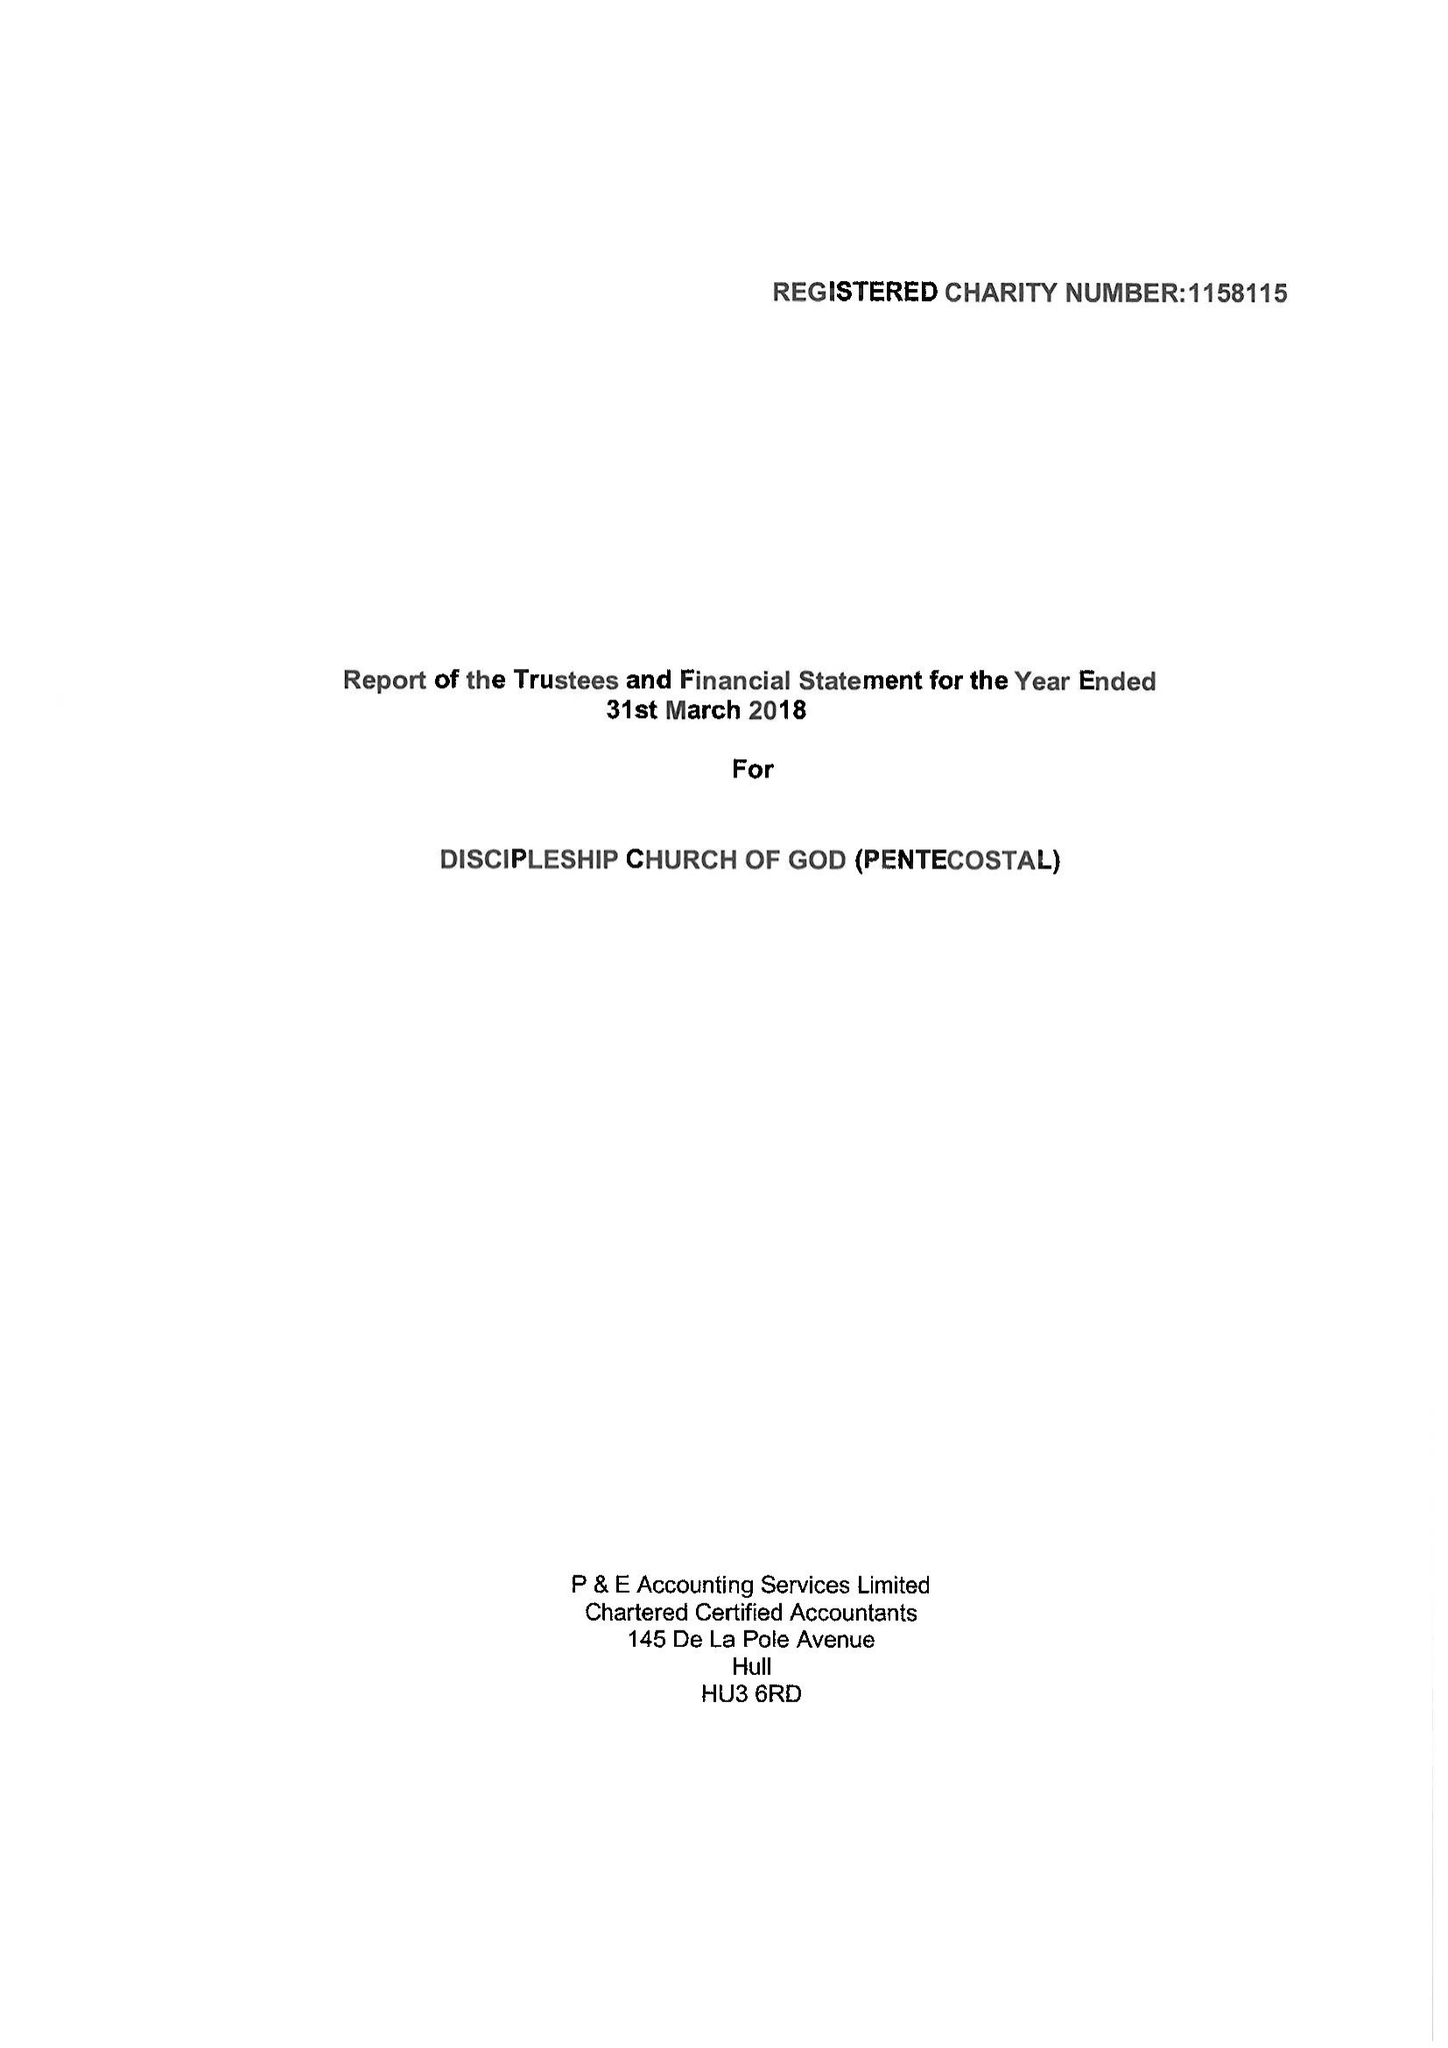What is the value for the charity_name?
Answer the question using a single word or phrase. Discipleship Church Of God (Pentecostal) 